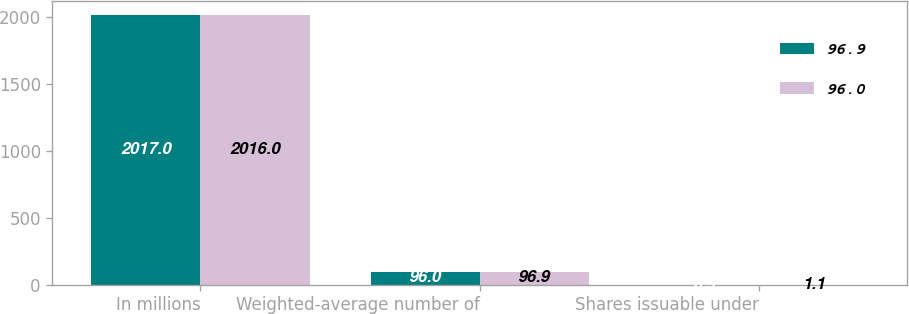Convert chart. <chart><loc_0><loc_0><loc_500><loc_500><stacked_bar_chart><ecel><fcel>In millions<fcel>Weighted-average number of<fcel>Shares issuable under<nl><fcel>96.9<fcel>2017<fcel>96<fcel>0.9<nl><fcel>96<fcel>2016<fcel>96.9<fcel>1.1<nl></chart> 